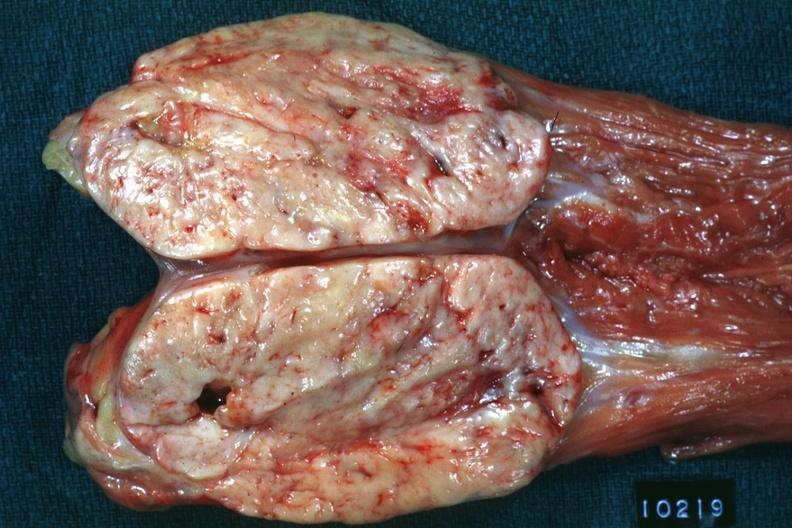what psoas natural color large ovoid typical sarcoma?
Answer the question using a single word or phrase. Opened muscle 